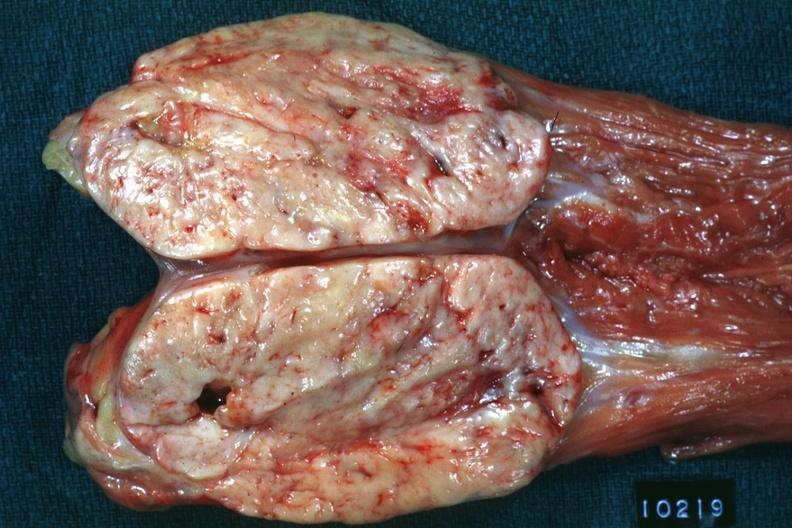what psoas natural color large ovoid typical sarcoma?
Answer the question using a single word or phrase. Opened muscle 